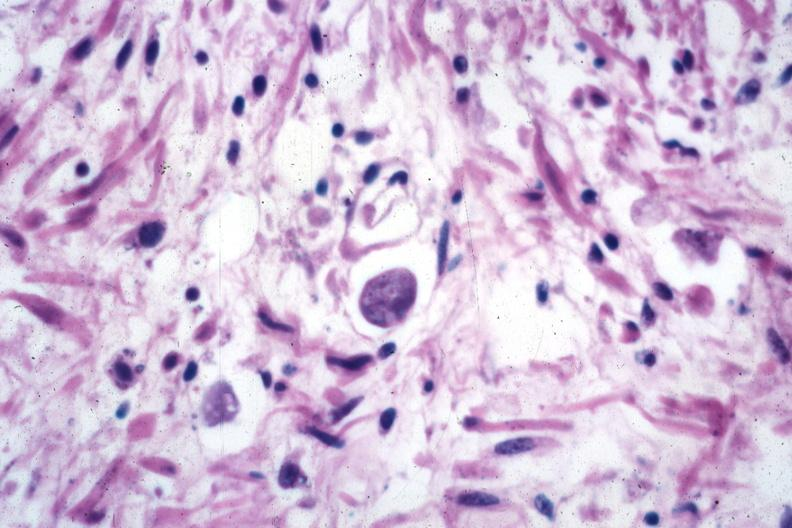does glomerulosa show trophozoite source?
Answer the question using a single word or phrase. No 